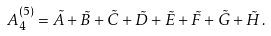<formula> <loc_0><loc_0><loc_500><loc_500>A _ { 4 } ^ { ( 5 ) } = \tilde { A } + \tilde { B } + \tilde { C } + \tilde { D } + \tilde { E } + \tilde { F } + \tilde { G } + \tilde { H } \, .</formula> 